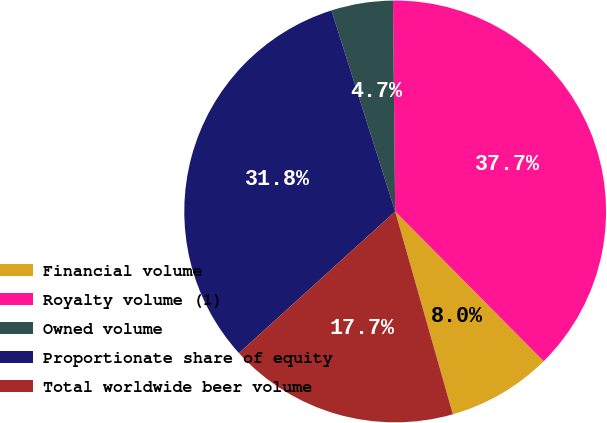<chart> <loc_0><loc_0><loc_500><loc_500><pie_chart><fcel>Financial volume<fcel>Royalty volume (1)<fcel>Owned volume<fcel>Proportionate share of equity<fcel>Total worldwide beer volume<nl><fcel>8.02%<fcel>37.74%<fcel>4.72%<fcel>31.84%<fcel>17.69%<nl></chart> 